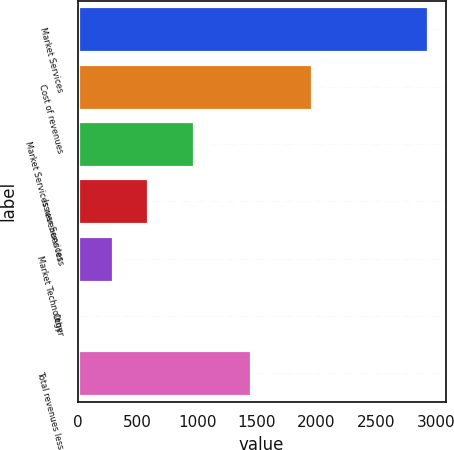<chart> <loc_0><loc_0><loc_500><loc_500><bar_chart><fcel>Market Services<fcel>Cost of revenues<fcel>Market Services revenues less<fcel>Issuer Services<fcel>Market Technology<fcel>Other<fcel>Total revenues less<nl><fcel>2934<fcel>1958<fcel>976<fcel>588.4<fcel>295.2<fcel>2<fcel>1453<nl></chart> 